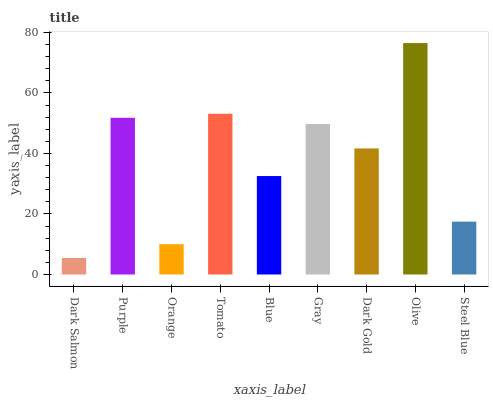Is Dark Salmon the minimum?
Answer yes or no. Yes. Is Olive the maximum?
Answer yes or no. Yes. Is Purple the minimum?
Answer yes or no. No. Is Purple the maximum?
Answer yes or no. No. Is Purple greater than Dark Salmon?
Answer yes or no. Yes. Is Dark Salmon less than Purple?
Answer yes or no. Yes. Is Dark Salmon greater than Purple?
Answer yes or no. No. Is Purple less than Dark Salmon?
Answer yes or no. No. Is Dark Gold the high median?
Answer yes or no. Yes. Is Dark Gold the low median?
Answer yes or no. Yes. Is Orange the high median?
Answer yes or no. No. Is Orange the low median?
Answer yes or no. No. 